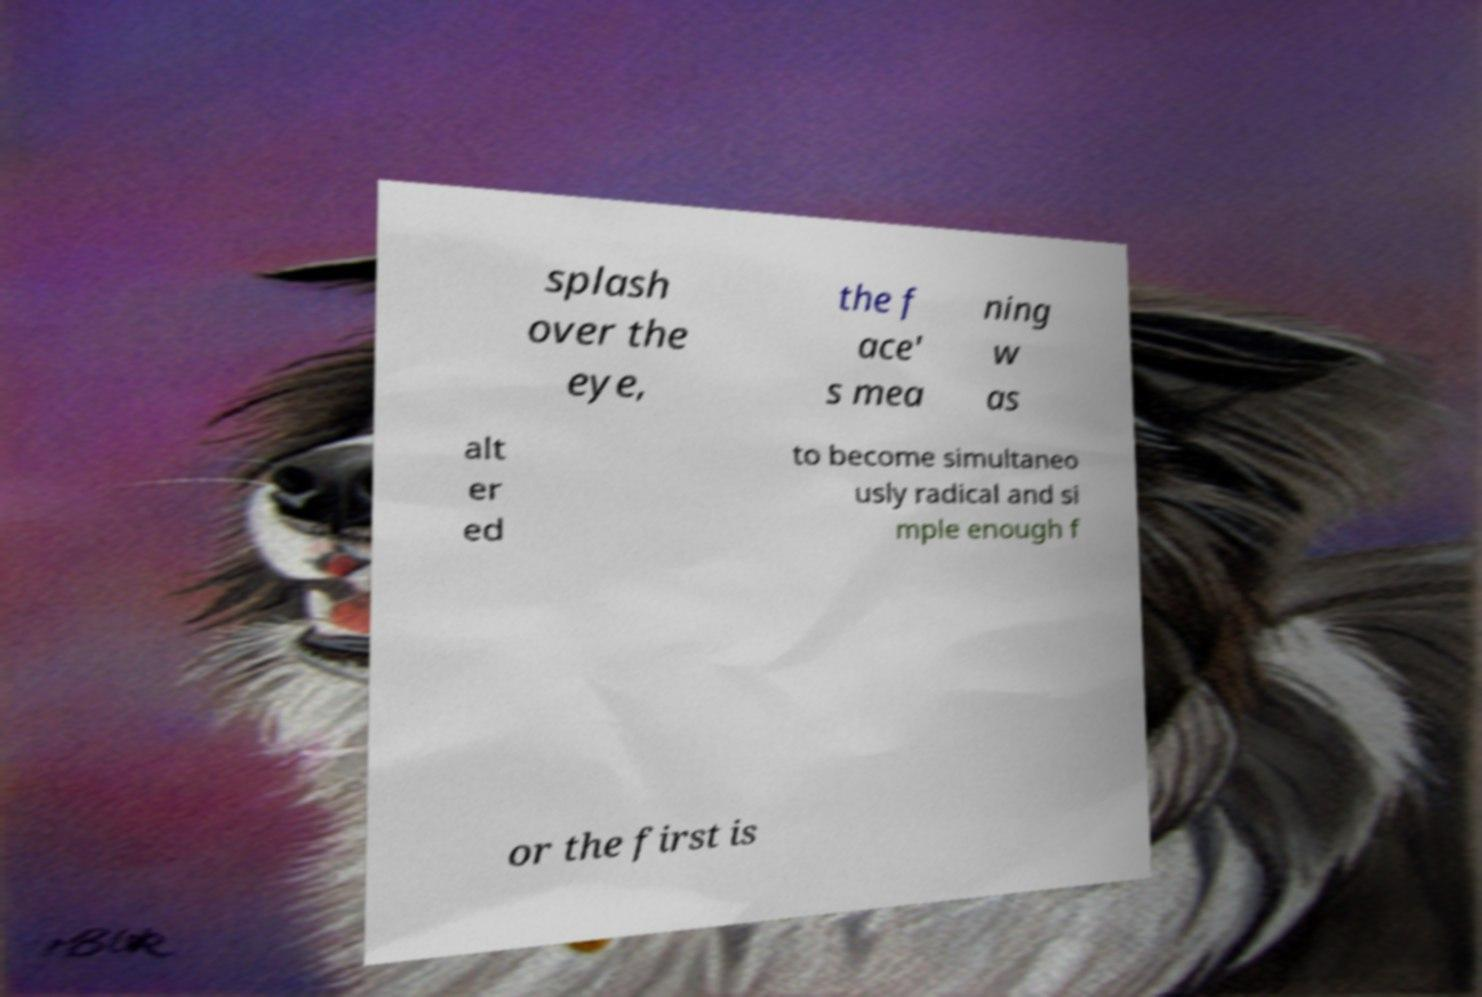Could you extract and type out the text from this image? splash over the eye, the f ace' s mea ning w as alt er ed to become simultaneo usly radical and si mple enough f or the first is 